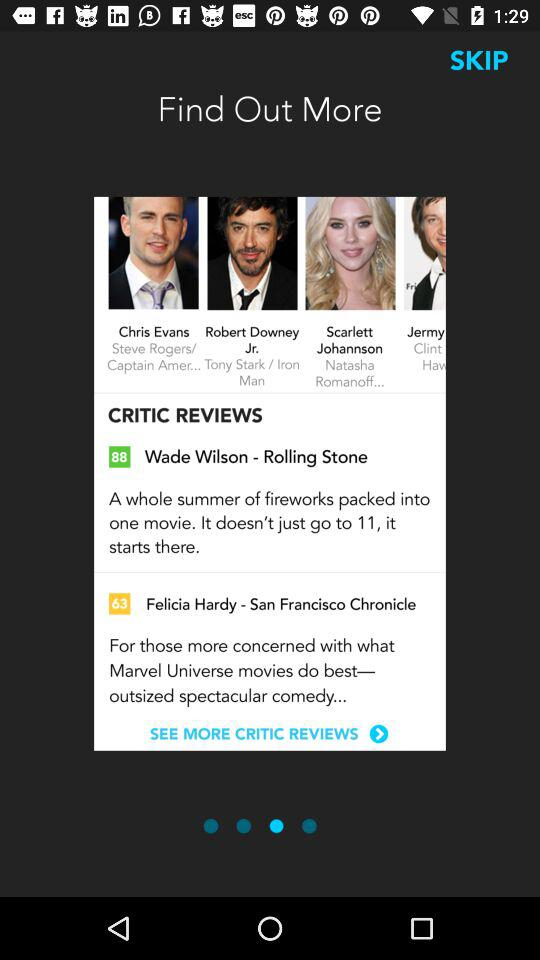What are the critics' reviews? The critics' reviews are "A whole summer of fireworks packed into one movie. It doesn't just go to 11, it starts there." and "For those more concerned with what Marvel Universe movies do best— outsized spectacular comedy...". 